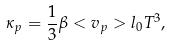<formula> <loc_0><loc_0><loc_500><loc_500>\kappa _ { p } = \frac { 1 } { 3 } \beta < v _ { p } > l _ { 0 } T ^ { 3 } ,</formula> 